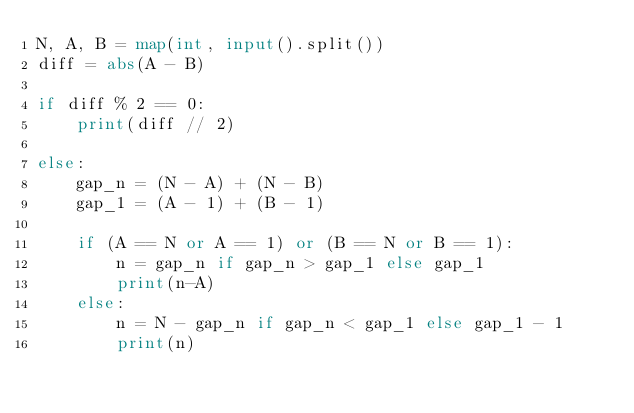Convert code to text. <code><loc_0><loc_0><loc_500><loc_500><_Python_>N, A, B = map(int, input().split())
diff = abs(A - B)

if diff % 2 == 0:
    print(diff // 2)

else:
    gap_n = (N - A) + (N - B)
    gap_1 = (A - 1) + (B - 1)

    if (A == N or A == 1) or (B == N or B == 1):
        n = gap_n if gap_n > gap_1 else gap_1
        print(n-A)
    else:
        n = N - gap_n if gap_n < gap_1 else gap_1 - 1
        print(n)
</code> 